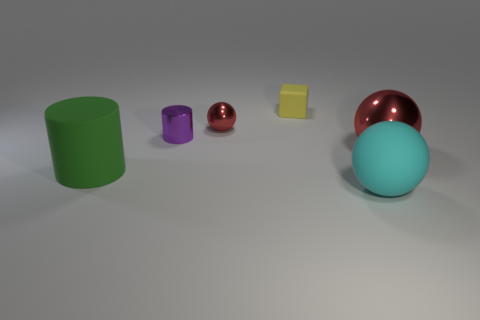Subtract all small balls. How many balls are left? 2 Subtract all blue cylinders. How many red balls are left? 2 Add 4 large cyan objects. How many objects exist? 10 Subtract all cyan balls. How many balls are left? 2 Subtract all cylinders. How many objects are left? 4 Subtract all tiny red metal balls. Subtract all red metallic objects. How many objects are left? 3 Add 4 yellow blocks. How many yellow blocks are left? 5 Add 4 tiny objects. How many tiny objects exist? 7 Subtract 0 green balls. How many objects are left? 6 Subtract all purple cylinders. Subtract all yellow balls. How many cylinders are left? 1 